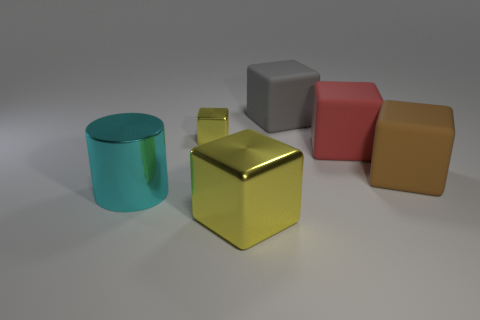What number of other objects are there of the same size as the cylinder?
Your answer should be compact. 4. Is there a large object to the right of the large cyan shiny thing that is behind the block that is in front of the cylinder?
Ensure brevity in your answer.  Yes. How many blocks are either big objects or gray things?
Offer a terse response. 4. Is the shape of the large yellow shiny object the same as the gray object behind the tiny object?
Offer a terse response. Yes. Are there fewer large brown rubber blocks to the left of the big yellow metallic thing than gray metal balls?
Offer a terse response. No. Are there any metal objects to the left of the large yellow metallic thing?
Keep it short and to the point. Yes. Are there any brown things of the same shape as the big gray thing?
Keep it short and to the point. Yes. What shape is the cyan object that is the same size as the gray thing?
Make the answer very short. Cylinder. What number of things are yellow shiny cubes in front of the big red rubber thing or cyan matte cylinders?
Offer a terse response. 1. Does the small metallic thing have the same color as the big metal cube?
Ensure brevity in your answer.  Yes. 